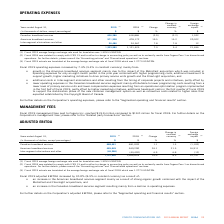According to Cogeco's financial document, What was the exchange rate in 2019? According to the financial document, 1.3255 USD/CDN.. The relevant text states: "age foreign exchange rate used for translation was 1.3255 USD/CDN...." Also, What was the exchange rate in 2018? According to the financial document, 1.2773 USD/CDN.. The relevant text states: "age foreign exchange rate of fiscal 2018 which was 1.2773 USD/CDN...." Also, What was the increase in 2019 EBITDA? According to the financial document, 10.0%. The relevant text states: "Fiscal 2019 adjusted EBITDA increased by 10.0% (8.5% in constant currency) as a result of:..." Also, can you calculate: What was the increase / (decrease) in Canadian broadband services from 2018 to 2019? Based on the calculation: 688,681 - 681,020, the result is 7661 (in thousands). This is based on the information: "Canadian broadband services 688,681 681,020 1.1 1.3 (1,102) Canadian broadband services 688,681 681,020 1.1 1.3 (1,102)..." The key data points involved are: 681,020, 688,681. Also, can you calculate: What was the average American broadband services between 2018 and 2019? To answer this question, I need to perform calculations using the financial data. The calculation is: (465,645 + 369,200) / 2, which equals 417422.5 (in thousands). This is based on the information: "American broadband services 465,645 369,200 26.1 21.5 16,911 American broadband services 465,645 369,200 26.1 21.5 16,911..." The key data points involved are: 369,200, 465,645. Also, can you calculate: What was the increase / (decrease) in the Inter-segment eliminations and other from 2018 to 2019? Based on the calculation: (-46,386) - (-43,402), the result is -2984 (in thousands). This is based on the information: "Inter-segment eliminations and other (46,386) (43,402) 6.9 6.8 (12) Inter-segment eliminations and other (46,386) (43,402) 6.9 6.8 (12)..." The key data points involved are: 43,402, 46,386. 